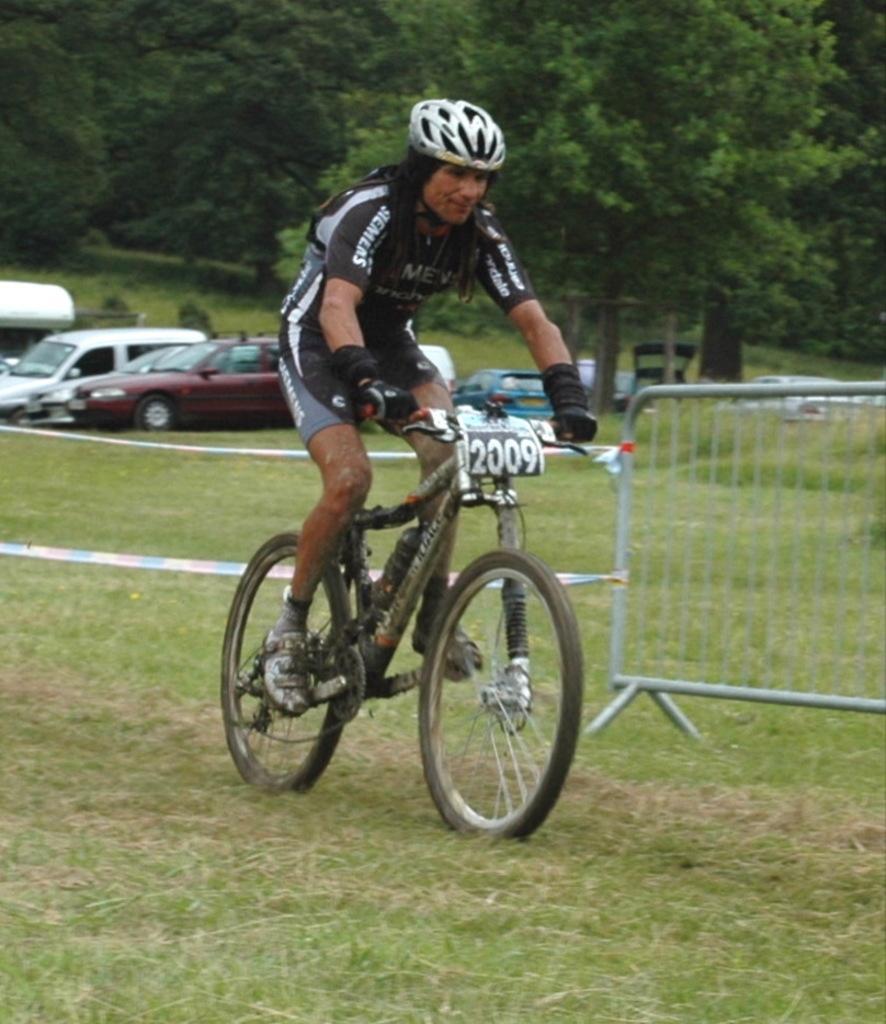In one or two sentences, can you explain what this image depicts? In this image we can see a person wearing sports dress, helmet, gloves and shoes riding bicycle and in the background of the image there is fencing, there are some vehicles parked and there are some trees. 